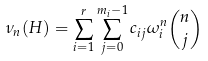Convert formula to latex. <formula><loc_0><loc_0><loc_500><loc_500>\nu _ { n } ( H ) = \sum _ { i = 1 } ^ { r } \sum _ { j = 0 } ^ { m _ { i } - 1 } c _ { i j } \omega _ { i } ^ { n } \binom { n } { j }</formula> 